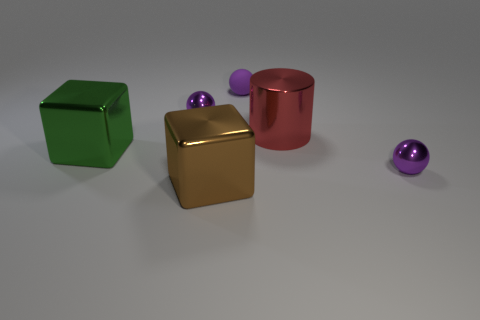Is there a large green thing that has the same material as the brown object?
Your answer should be very brief. Yes. There is a big shiny block behind the shiny ball to the right of the red metallic cylinder; are there any big red cylinders that are in front of it?
Provide a short and direct response. No. How many other things are the same shape as the brown thing?
Ensure brevity in your answer.  1. What color is the small sphere that is in front of the large metal thing to the left of the tiny purple shiny object that is behind the big red cylinder?
Ensure brevity in your answer.  Purple. How many large objects are there?
Offer a very short reply. 3. What number of big objects are metal cylinders or brown metal cylinders?
Provide a succinct answer. 1. What is the shape of the brown object that is the same size as the red thing?
Provide a short and direct response. Cube. Are there any other things that have the same size as the red metal cylinder?
Offer a very short reply. Yes. There is a block behind the tiny ball that is in front of the large red metallic object; what is its material?
Your response must be concise. Metal. Is the green metallic object the same size as the shiny cylinder?
Give a very brief answer. Yes. 